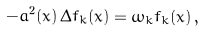<formula> <loc_0><loc_0><loc_500><loc_500>- a ^ { 2 } ( x ) \, \Delta f _ { k } ( x ) = \omega _ { k } f _ { k } ( x ) \, { , }</formula> 